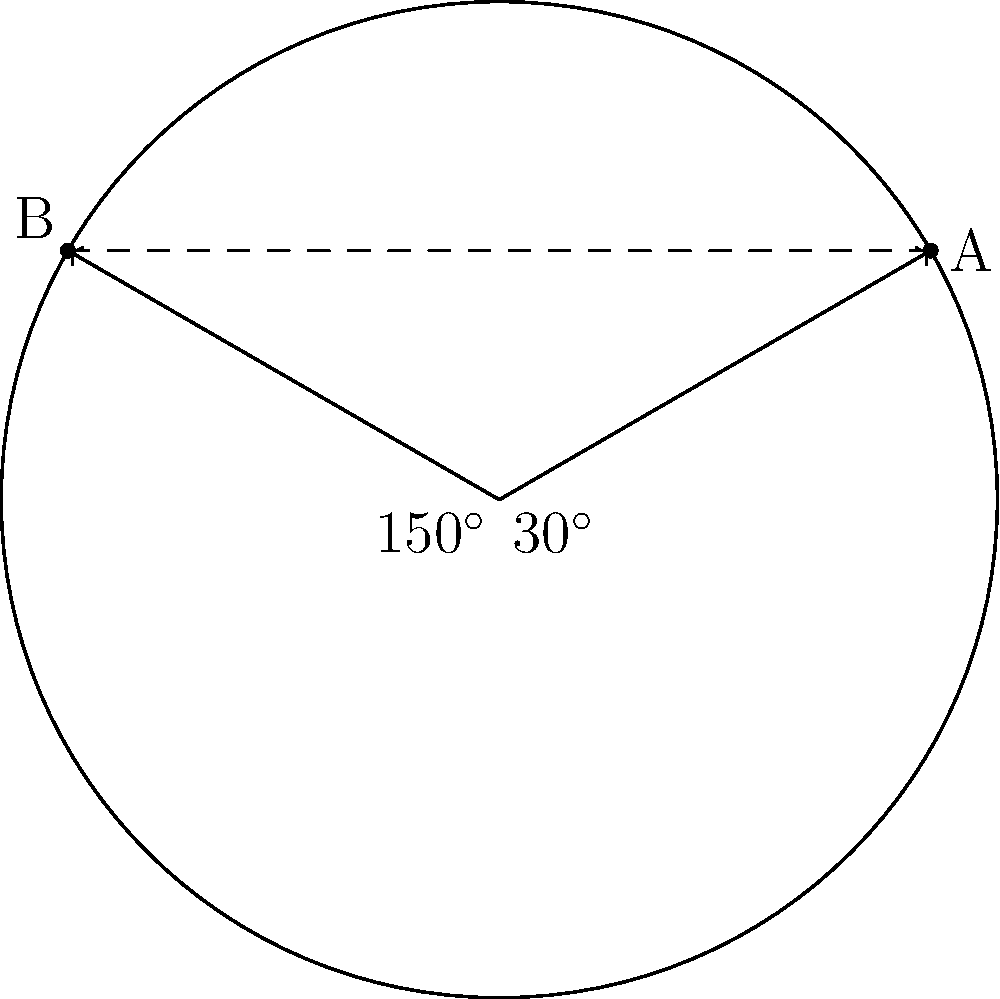In the 1961 Pan American Games, two runners, A and B, were positioned on a circular track. Using the polar coordinate system with the center of the track as the origin, runner A was at $30^\circ$ and runner B at $150^\circ$. If the radius of the track is 100 meters, what is the straight-line distance between the two runners? Round your answer to the nearest meter. To solve this problem, we'll use the following steps:

1) In polar coordinates, the positions of the runners are:
   A: $(r, 30^\circ)$
   B: $(r, 150^\circ)$
   where $r = 100$ meters (the radius of the track)

2) To find the distance between two points in polar coordinates, we can use the formula:

   $d = \sqrt{r_1^2 + r_2^2 - 2r_1r_2\cos(\theta_2 - \theta_1)}$

   where $(r_1, \theta_1)$ and $(r_2, \theta_2)$ are the polar coordinates of the two points.

3) In this case, $r_1 = r_2 = r = 100$ meters, $\theta_1 = 30^\circ$, and $\theta_2 = 150^\circ$

4) Plugging these values into the formula:

   $d = \sqrt{100^2 + 100^2 - 2(100)(100)\cos(150^\circ - 30^\circ)}$

5) Simplify:
   $d = \sqrt{10000 + 10000 - 20000\cos(120^\circ)}$

6) $\cos(120^\circ) = -0.5$, so:
   $d = \sqrt{20000 + 10000}$
   $d = \sqrt{30000}$

7) Calculate and round to the nearest meter:
   $d \approx 173$ meters
Answer: 173 meters 